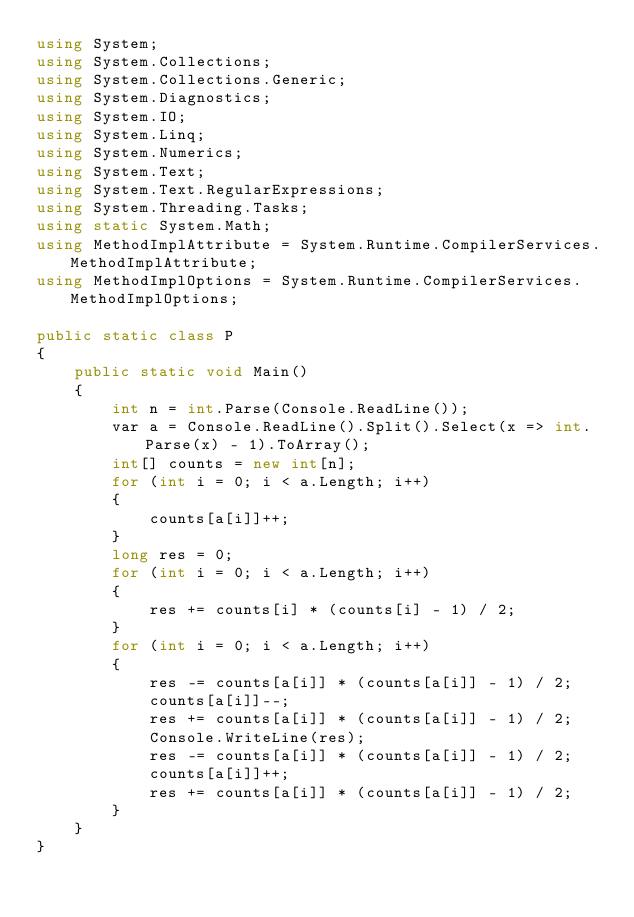Convert code to text. <code><loc_0><loc_0><loc_500><loc_500><_C#_>using System;
using System.Collections;
using System.Collections.Generic;
using System.Diagnostics;
using System.IO;
using System.Linq;
using System.Numerics;
using System.Text;
using System.Text.RegularExpressions;
using System.Threading.Tasks;
using static System.Math;
using MethodImplAttribute = System.Runtime.CompilerServices.MethodImplAttribute;
using MethodImplOptions = System.Runtime.CompilerServices.MethodImplOptions;

public static class P
{
    public static void Main()
    {
        int n = int.Parse(Console.ReadLine());
        var a = Console.ReadLine().Split().Select(x => int.Parse(x) - 1).ToArray();
        int[] counts = new int[n];
        for (int i = 0; i < a.Length; i++)
        {
            counts[a[i]]++;
        }
        long res = 0;
        for (int i = 0; i < a.Length; i++)
        {
            res += counts[i] * (counts[i] - 1) / 2;
        }
        for (int i = 0; i < a.Length; i++)
        {
            res -= counts[a[i]] * (counts[a[i]] - 1) / 2;
            counts[a[i]]--;
            res += counts[a[i]] * (counts[a[i]] - 1) / 2;
            Console.WriteLine(res);
            res -= counts[a[i]] * (counts[a[i]] - 1) / 2;
            counts[a[i]]++;
            res += counts[a[i]] * (counts[a[i]] - 1) / 2;
        }
    }
}
</code> 